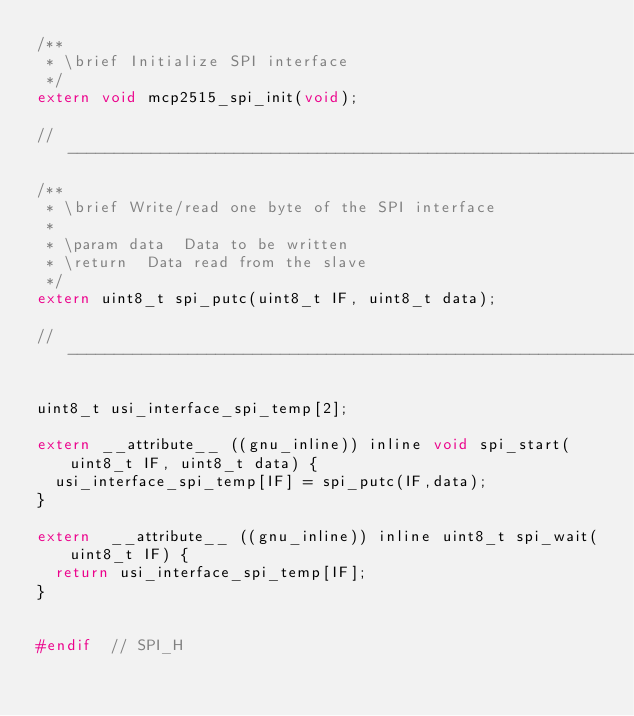Convert code to text. <code><loc_0><loc_0><loc_500><loc_500><_C_>/**
 * \brief	Initialize SPI interface
 */
extern void mcp2515_spi_init(void);

// ----------------------------------------------------------------------------
/**
 * \brief	Write/read one byte of the SPI interface
 *
 * \param	data	Data to be written
 * \return	Data read from the slave
 */
extern uint8_t spi_putc(uint8_t IF, uint8_t data);

// ----------------------------------------------------------------------------

uint8_t usi_interface_spi_temp[2];

extern __attribute__ ((gnu_inline)) inline void spi_start(uint8_t IF, uint8_t data) {
	usi_interface_spi_temp[IF] = spi_putc(IF,data);
}

extern  __attribute__ ((gnu_inline)) inline uint8_t spi_wait(uint8_t IF) {
	return usi_interface_spi_temp[IF];
}


#endif	// SPI_H
</code> 